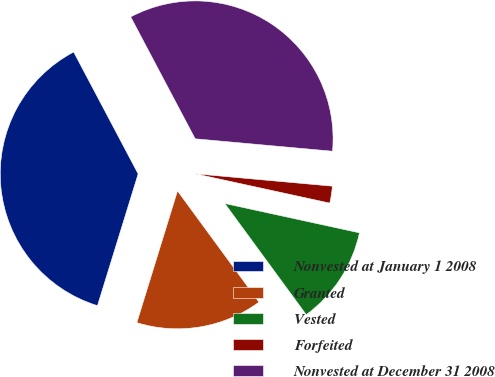Convert chart. <chart><loc_0><loc_0><loc_500><loc_500><pie_chart><fcel>Nonvested at January 1 2008<fcel>Granted<fcel>Vested<fcel>Forfeited<fcel>Nonvested at December 31 2008<nl><fcel>37.49%<fcel>14.83%<fcel>11.52%<fcel>1.98%<fcel>34.18%<nl></chart> 